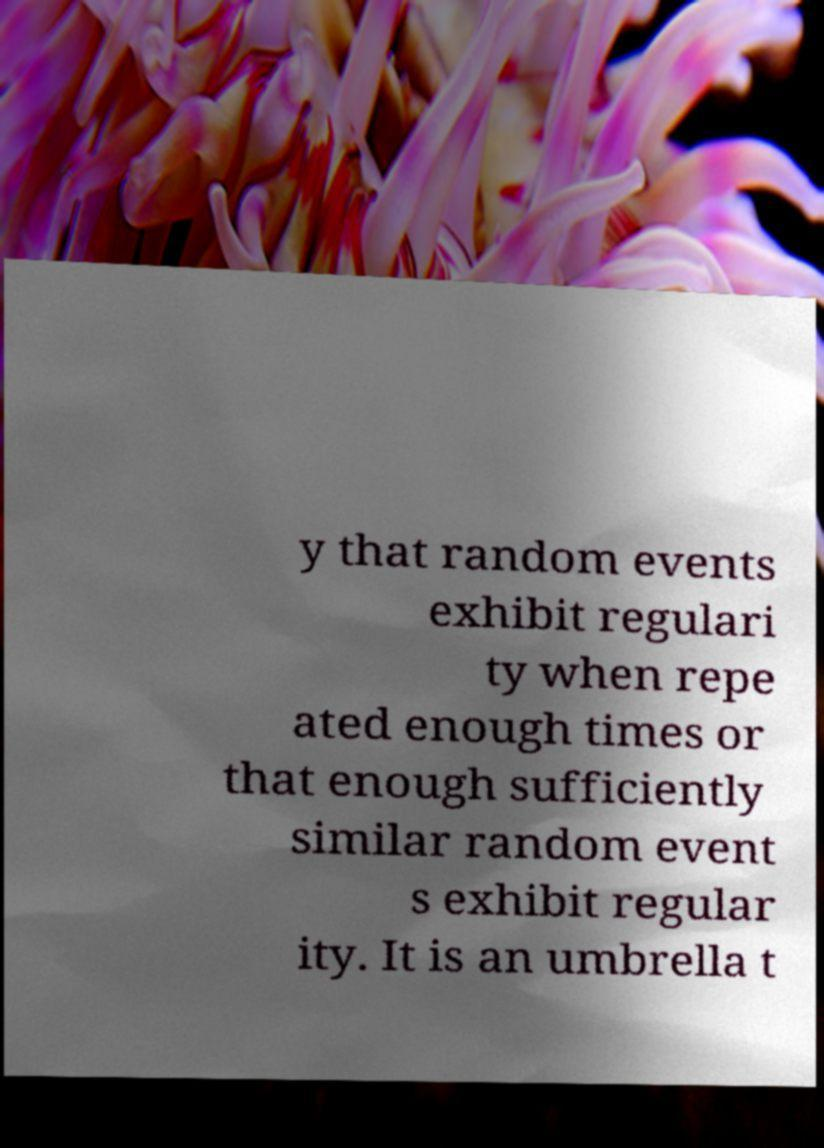Please read and relay the text visible in this image. What does it say? y that random events exhibit regulari ty when repe ated enough times or that enough sufficiently similar random event s exhibit regular ity. It is an umbrella t 